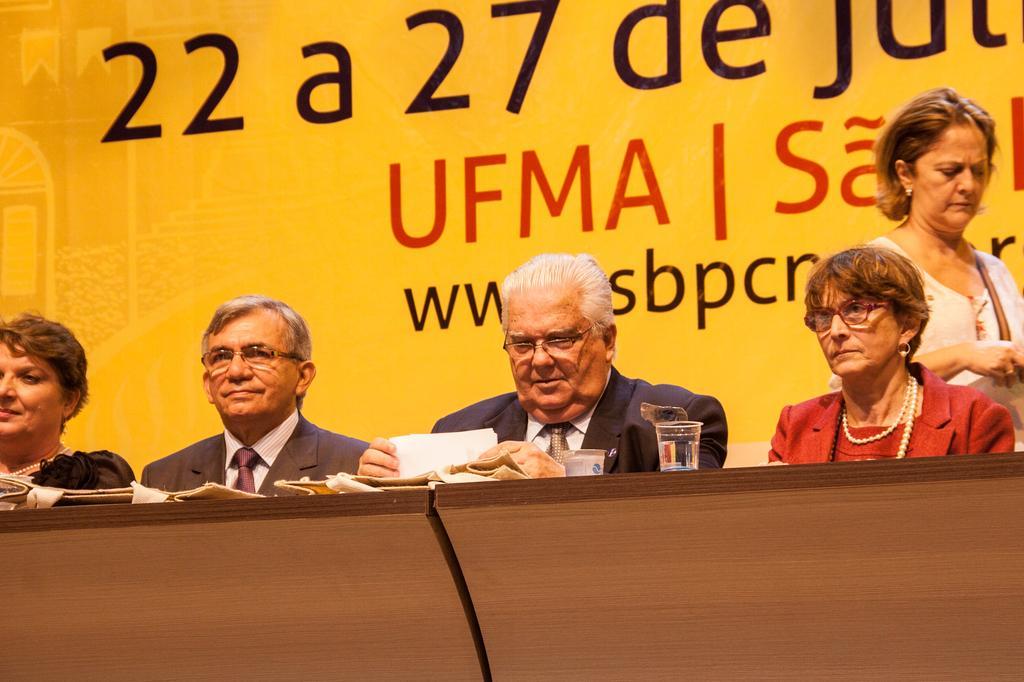Please provide a concise description of this image. In this image we can see people, glass, papers, wooden object and in the background, we can see a poster with some text. 